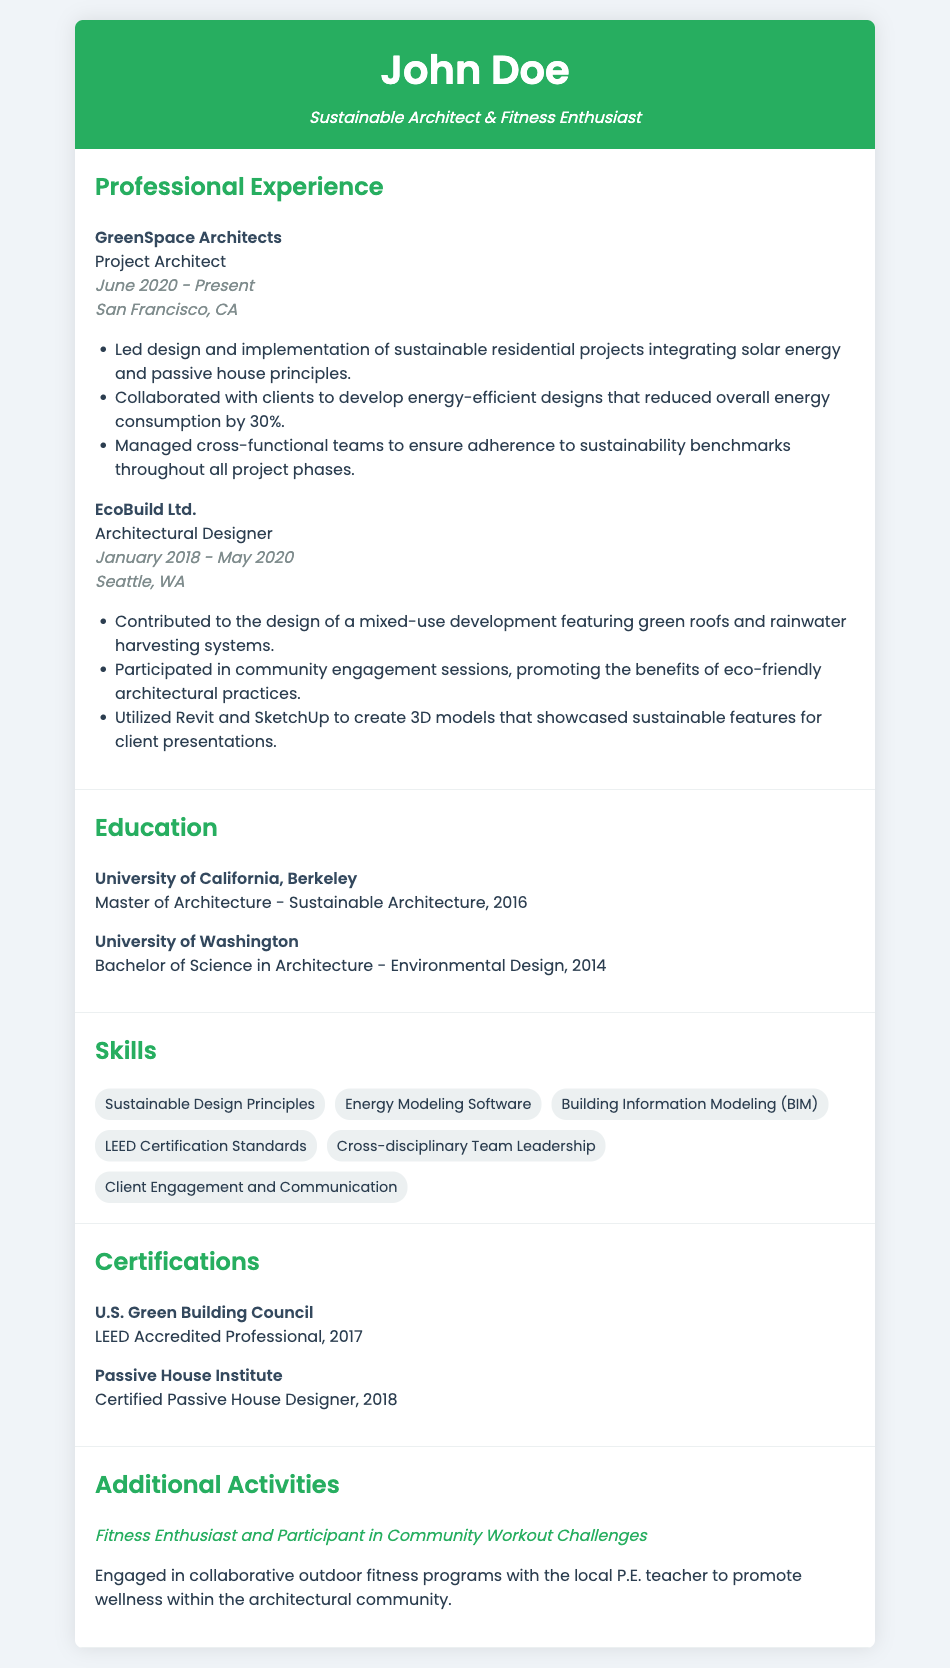What is the name of the current employer? The current employer is mentioned in the work experience section of the resume, which shows "GreenSpace Architects."
Answer: GreenSpace Architects What is the position held at GreenSpace Architects? The position held is specified next to the employer in the document, stating "Project Architect."
Answer: Project Architect When did the applicant start working at EcoBuild Ltd.? The start date can be found in the dates section of their experience at EcoBuild Ltd., which is "January 2018."
Answer: January 2018 What kind of architectural design did the applicant focus on at GreenSpace Architects? The document mentions that the applicant led projects integrating "solar energy and passive house principles."
Answer: Solar energy and passive house principles How many years of experience does the applicant have at their current job? The current job start date is June 2020, and considering the end date is unspecified (current), we can determine they have more than 3 years of experience as of the present date (October 2023).
Answer: Over 3 years Which degree was obtained at the University of California, Berkeley? The resume lists the degree obtained, providing the information that it is "Master of Architecture - Sustainable Architecture."
Answer: Master of Architecture - Sustainable Architecture What certification was earned from the Passive House Institute? The certification listed is "Certified Passive House Designer."
Answer: Certified Passive House Designer What type of activities does the applicant engage in with the local P.E. teacher? The document outlines the applicant's participation in "collaborative outdoor fitness programs."
Answer: Collaborative outdoor fitness programs 